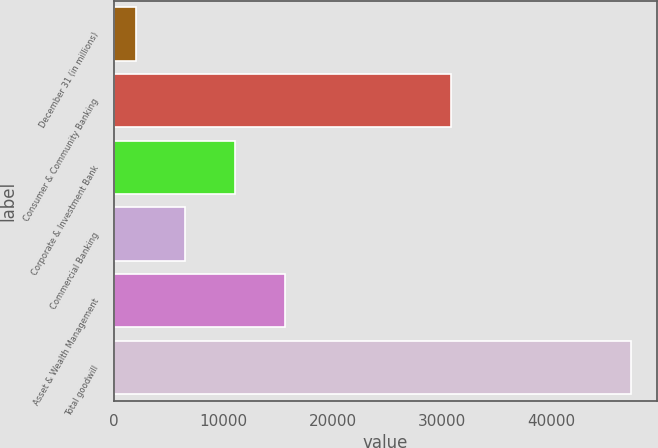<chart> <loc_0><loc_0><loc_500><loc_500><bar_chart><fcel>December 31 (in millions)<fcel>Consumer & Community Banking<fcel>Corporate & Investment Bank<fcel>Commercial Banking<fcel>Asset & Wealth Management<fcel>Total goodwill<nl><fcel>2016<fcel>30797<fcel>11070.4<fcel>6543.2<fcel>15597.6<fcel>47288<nl></chart> 